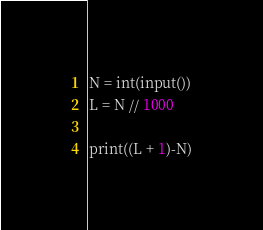<code> <loc_0><loc_0><loc_500><loc_500><_Python_>N = int(input())
L = N // 1000

print((L + 1)-N)</code> 